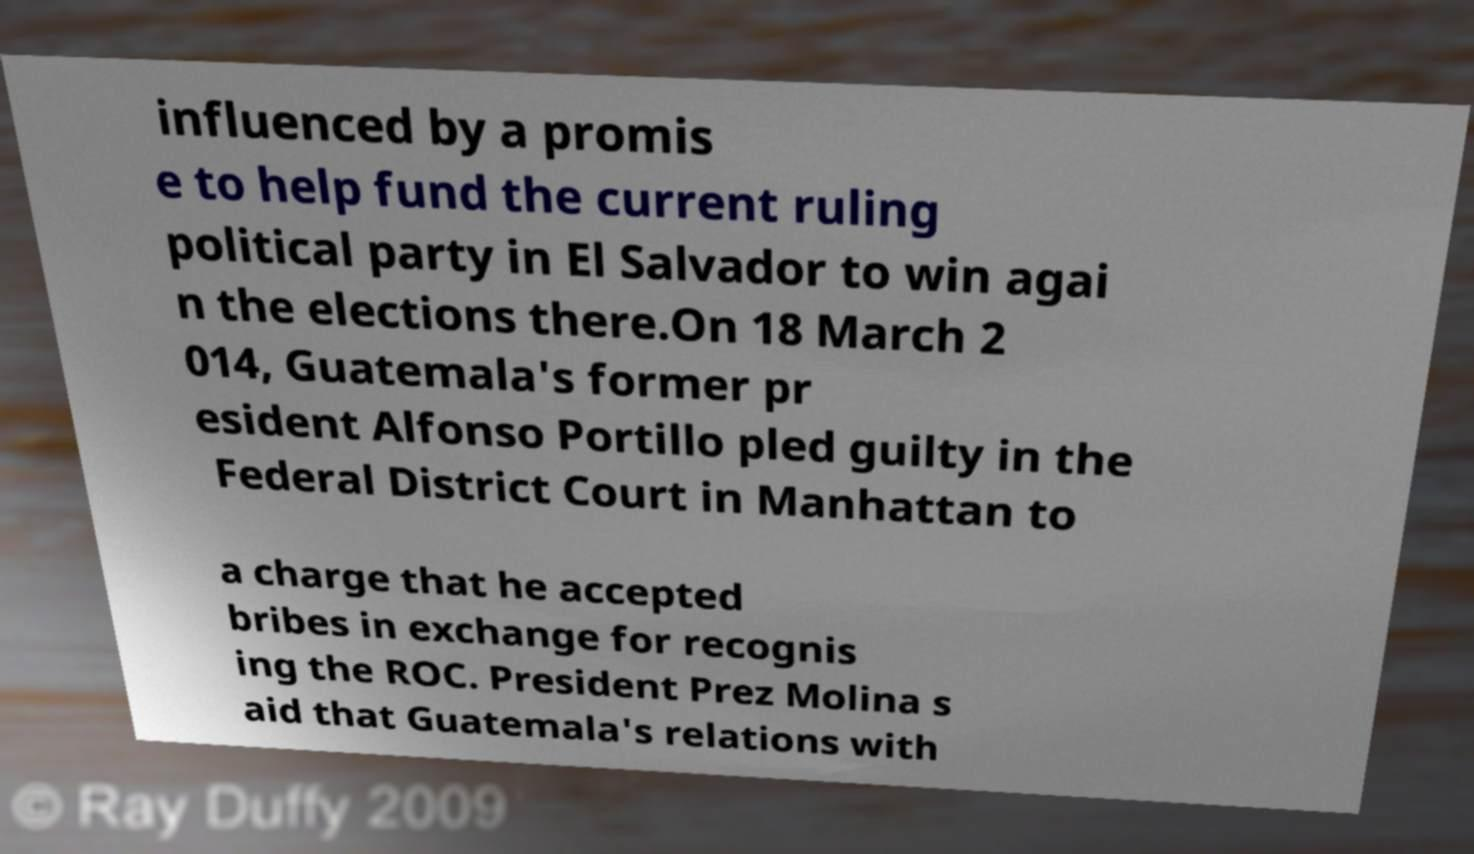For documentation purposes, I need the text within this image transcribed. Could you provide that? influenced by a promis e to help fund the current ruling political party in El Salvador to win agai n the elections there.On 18 March 2 014, Guatemala's former pr esident Alfonso Portillo pled guilty in the Federal District Court in Manhattan to a charge that he accepted bribes in exchange for recognis ing the ROC. President Prez Molina s aid that Guatemala's relations with 